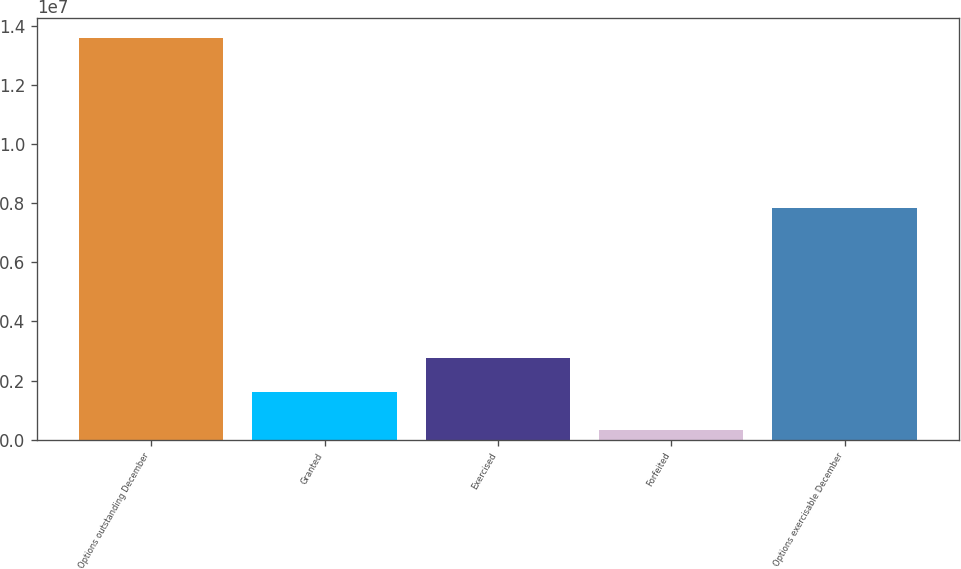Convert chart. <chart><loc_0><loc_0><loc_500><loc_500><bar_chart><fcel>Options outstanding December<fcel>Granted<fcel>Exercised<fcel>Forfeited<fcel>Options exercisable December<nl><fcel>1.35976e+07<fcel>1.61251e+06<fcel>2.77589e+06<fcel>309026<fcel>7.83922e+06<nl></chart> 